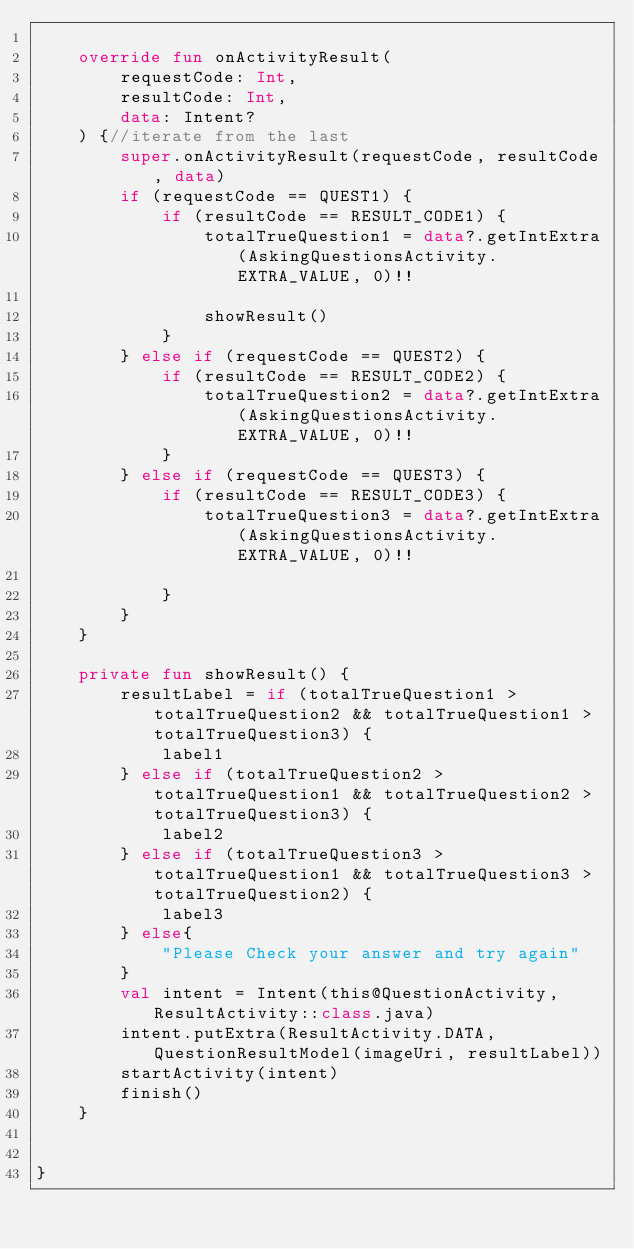<code> <loc_0><loc_0><loc_500><loc_500><_Kotlin_>
    override fun onActivityResult(
        requestCode: Int,
        resultCode: Int,
        data: Intent?
    ) {//iterate from the last
        super.onActivityResult(requestCode, resultCode, data)
        if (requestCode == QUEST1) {
            if (resultCode == RESULT_CODE1) {
                totalTrueQuestion1 = data?.getIntExtra(AskingQuestionsActivity.EXTRA_VALUE, 0)!!

                showResult()
            }
        } else if (requestCode == QUEST2) {
            if (resultCode == RESULT_CODE2) {
                totalTrueQuestion2 = data?.getIntExtra(AskingQuestionsActivity.EXTRA_VALUE, 0)!!
            }
        } else if (requestCode == QUEST3) {
            if (resultCode == RESULT_CODE3) {
                totalTrueQuestion3 = data?.getIntExtra(AskingQuestionsActivity.EXTRA_VALUE, 0)!!

            }
        }
    }

    private fun showResult() {
        resultLabel = if (totalTrueQuestion1 > totalTrueQuestion2 && totalTrueQuestion1 > totalTrueQuestion3) {
            label1
        } else if (totalTrueQuestion2 > totalTrueQuestion1 && totalTrueQuestion2 > totalTrueQuestion3) {
            label2
        } else if (totalTrueQuestion3 > totalTrueQuestion1 && totalTrueQuestion3 > totalTrueQuestion2) {
            label3
        } else{
            "Please Check your answer and try again"
        }
        val intent = Intent(this@QuestionActivity, ResultActivity::class.java)
        intent.putExtra(ResultActivity.DATA, QuestionResultModel(imageUri, resultLabel))
        startActivity(intent)
        finish()
    }


}</code> 